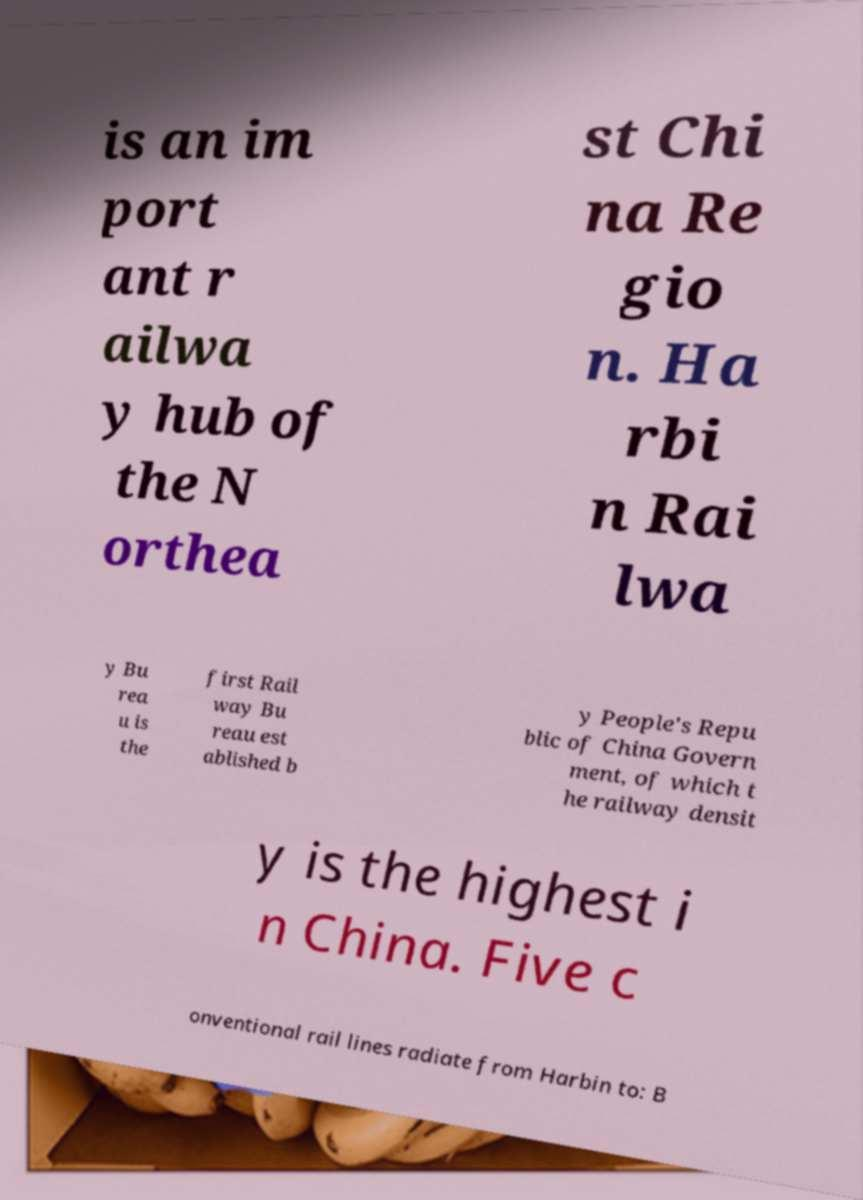Please read and relay the text visible in this image. What does it say? is an im port ant r ailwa y hub of the N orthea st Chi na Re gio n. Ha rbi n Rai lwa y Bu rea u is the first Rail way Bu reau est ablished b y People's Repu blic of China Govern ment, of which t he railway densit y is the highest i n China. Five c onventional rail lines radiate from Harbin to: B 